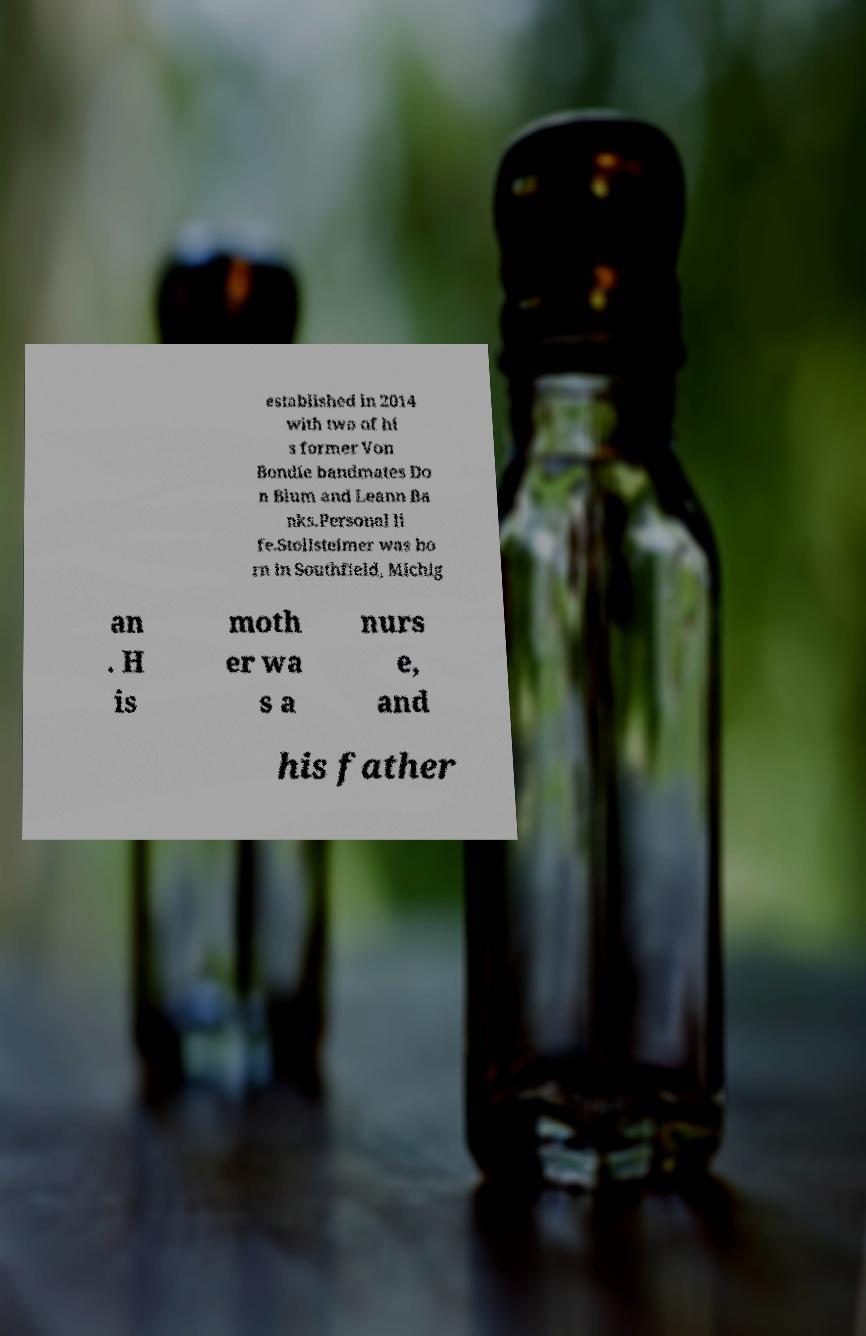For documentation purposes, I need the text within this image transcribed. Could you provide that? established in 2014 with two of hi s former Von Bondie bandmates Do n Blum and Leann Ba nks.Personal li fe.Stollsteimer was bo rn in Southfield, Michig an . H is moth er wa s a nurs e, and his father 